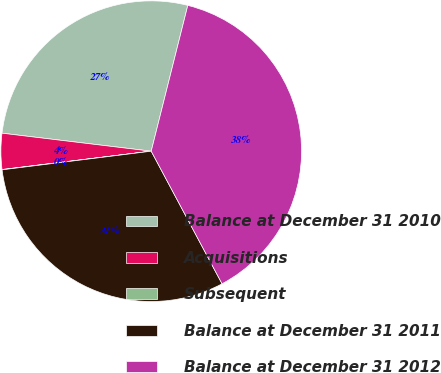Convert chart to OTSL. <chart><loc_0><loc_0><loc_500><loc_500><pie_chart><fcel>Balance at December 31 2010<fcel>Acquisitions<fcel>Subsequent<fcel>Balance at December 31 2011<fcel>Balance at December 31 2012<nl><fcel>27.0%<fcel>3.86%<fcel>0.03%<fcel>30.83%<fcel>38.28%<nl></chart> 